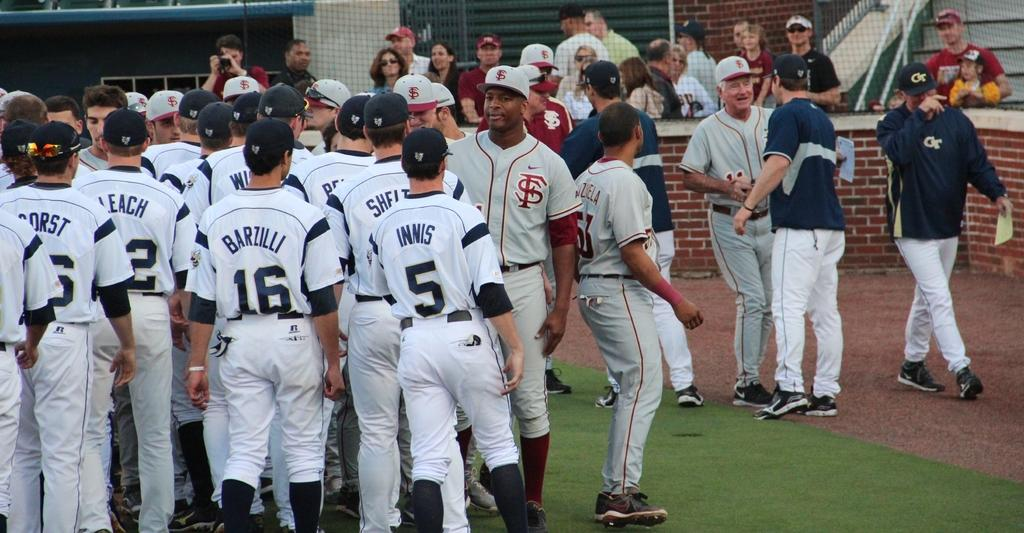<image>
Offer a succinct explanation of the picture presented. A bunch of baseball players including number 16 Barzilli and number 5 Innis stand on a field next to members of their opposing team. 